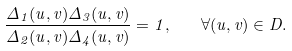Convert formula to latex. <formula><loc_0><loc_0><loc_500><loc_500>\frac { \Delta _ { 1 } ( u , v ) \Delta _ { 3 } ( u , v ) } { \Delta _ { 2 } ( u , v ) \Delta _ { 4 } ( u , v ) } = 1 , \quad \forall ( u , v ) \in D .</formula> 